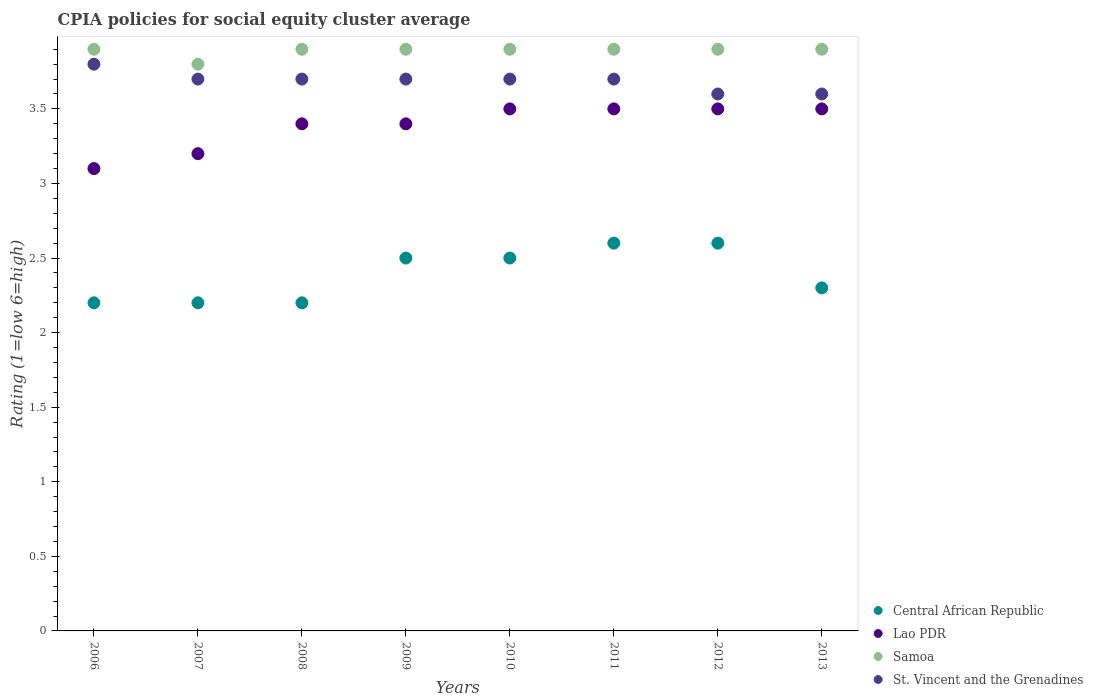How many different coloured dotlines are there?
Make the answer very short. 4. Is the number of dotlines equal to the number of legend labels?
Provide a succinct answer. Yes. Across all years, what is the maximum CPIA rating in St. Vincent and the Grenadines?
Offer a very short reply. 3.8. Across all years, what is the minimum CPIA rating in Lao PDR?
Your answer should be compact. 3.1. In which year was the CPIA rating in St. Vincent and the Grenadines minimum?
Ensure brevity in your answer.  2012. What is the total CPIA rating in Lao PDR in the graph?
Ensure brevity in your answer.  27.1. What is the difference between the CPIA rating in St. Vincent and the Grenadines in 2006 and the CPIA rating in Samoa in 2010?
Provide a succinct answer. -0.1. What is the average CPIA rating in St. Vincent and the Grenadines per year?
Ensure brevity in your answer.  3.69. In the year 2012, what is the difference between the CPIA rating in Lao PDR and CPIA rating in Central African Republic?
Keep it short and to the point. 0.9. What is the ratio of the CPIA rating in Lao PDR in 2006 to that in 2008?
Give a very brief answer. 0.91. Is the CPIA rating in Central African Republic in 2009 less than that in 2012?
Give a very brief answer. Yes. What is the difference between the highest and the second highest CPIA rating in St. Vincent and the Grenadines?
Keep it short and to the point. 0.1. What is the difference between the highest and the lowest CPIA rating in Samoa?
Make the answer very short. 0.1. In how many years, is the CPIA rating in Samoa greater than the average CPIA rating in Samoa taken over all years?
Give a very brief answer. 7. Is the sum of the CPIA rating in Lao PDR in 2008 and 2010 greater than the maximum CPIA rating in St. Vincent and the Grenadines across all years?
Provide a short and direct response. Yes. Does the CPIA rating in Central African Republic monotonically increase over the years?
Give a very brief answer. No. Is the CPIA rating in Lao PDR strictly greater than the CPIA rating in Samoa over the years?
Ensure brevity in your answer.  No. Is the CPIA rating in Samoa strictly less than the CPIA rating in Lao PDR over the years?
Provide a succinct answer. No. How many dotlines are there?
Offer a very short reply. 4. How many years are there in the graph?
Ensure brevity in your answer.  8. Are the values on the major ticks of Y-axis written in scientific E-notation?
Your answer should be very brief. No. Does the graph contain any zero values?
Offer a very short reply. No. Does the graph contain grids?
Your answer should be very brief. No. Where does the legend appear in the graph?
Provide a short and direct response. Bottom right. How many legend labels are there?
Provide a short and direct response. 4. How are the legend labels stacked?
Keep it short and to the point. Vertical. What is the title of the graph?
Ensure brevity in your answer.  CPIA policies for social equity cluster average. What is the label or title of the X-axis?
Give a very brief answer. Years. What is the Rating (1=low 6=high) of Lao PDR in 2006?
Ensure brevity in your answer.  3.1. What is the Rating (1=low 6=high) in St. Vincent and the Grenadines in 2006?
Give a very brief answer. 3.8. What is the Rating (1=low 6=high) of St. Vincent and the Grenadines in 2007?
Give a very brief answer. 3.7. What is the Rating (1=low 6=high) in Lao PDR in 2008?
Provide a succinct answer. 3.4. What is the Rating (1=low 6=high) in Samoa in 2008?
Your answer should be compact. 3.9. What is the Rating (1=low 6=high) of Samoa in 2010?
Offer a terse response. 3.9. What is the Rating (1=low 6=high) in St. Vincent and the Grenadines in 2010?
Make the answer very short. 3.7. What is the Rating (1=low 6=high) in Central African Republic in 2011?
Provide a succinct answer. 2.6. What is the Rating (1=low 6=high) of Lao PDR in 2011?
Provide a succinct answer. 3.5. What is the Rating (1=low 6=high) in Samoa in 2011?
Offer a terse response. 3.9. What is the Rating (1=low 6=high) of Central African Republic in 2012?
Ensure brevity in your answer.  2.6. What is the Rating (1=low 6=high) in Lao PDR in 2012?
Keep it short and to the point. 3.5. What is the Rating (1=low 6=high) in Samoa in 2012?
Make the answer very short. 3.9. What is the Rating (1=low 6=high) of St. Vincent and the Grenadines in 2012?
Your response must be concise. 3.6. What is the Rating (1=low 6=high) of Central African Republic in 2013?
Make the answer very short. 2.3. What is the Rating (1=low 6=high) in Lao PDR in 2013?
Make the answer very short. 3.5. Across all years, what is the maximum Rating (1=low 6=high) of Central African Republic?
Offer a terse response. 2.6. Across all years, what is the minimum Rating (1=low 6=high) in Samoa?
Offer a terse response. 3.8. Across all years, what is the minimum Rating (1=low 6=high) in St. Vincent and the Grenadines?
Offer a terse response. 3.6. What is the total Rating (1=low 6=high) of Lao PDR in the graph?
Give a very brief answer. 27.1. What is the total Rating (1=low 6=high) of Samoa in the graph?
Offer a very short reply. 31.1. What is the total Rating (1=low 6=high) in St. Vincent and the Grenadines in the graph?
Your response must be concise. 29.5. What is the difference between the Rating (1=low 6=high) in Central African Republic in 2006 and that in 2007?
Offer a very short reply. 0. What is the difference between the Rating (1=low 6=high) in Lao PDR in 2006 and that in 2007?
Make the answer very short. -0.1. What is the difference between the Rating (1=low 6=high) of Samoa in 2006 and that in 2007?
Offer a terse response. 0.1. What is the difference between the Rating (1=low 6=high) of Central African Republic in 2006 and that in 2008?
Your answer should be very brief. 0. What is the difference between the Rating (1=low 6=high) of St. Vincent and the Grenadines in 2006 and that in 2008?
Provide a succinct answer. 0.1. What is the difference between the Rating (1=low 6=high) of Central African Republic in 2006 and that in 2009?
Provide a short and direct response. -0.3. What is the difference between the Rating (1=low 6=high) of St. Vincent and the Grenadines in 2006 and that in 2009?
Provide a short and direct response. 0.1. What is the difference between the Rating (1=low 6=high) of Samoa in 2006 and that in 2010?
Your answer should be very brief. 0. What is the difference between the Rating (1=low 6=high) of Central African Republic in 2006 and that in 2011?
Give a very brief answer. -0.4. What is the difference between the Rating (1=low 6=high) of Lao PDR in 2006 and that in 2011?
Ensure brevity in your answer.  -0.4. What is the difference between the Rating (1=low 6=high) in St. Vincent and the Grenadines in 2006 and that in 2011?
Keep it short and to the point. 0.1. What is the difference between the Rating (1=low 6=high) of Samoa in 2006 and that in 2012?
Provide a succinct answer. 0. What is the difference between the Rating (1=low 6=high) of Central African Republic in 2006 and that in 2013?
Your response must be concise. -0.1. What is the difference between the Rating (1=low 6=high) in Lao PDR in 2006 and that in 2013?
Offer a very short reply. -0.4. What is the difference between the Rating (1=low 6=high) of Samoa in 2006 and that in 2013?
Ensure brevity in your answer.  0. What is the difference between the Rating (1=low 6=high) in St. Vincent and the Grenadines in 2006 and that in 2013?
Offer a very short reply. 0.2. What is the difference between the Rating (1=low 6=high) of Lao PDR in 2007 and that in 2008?
Provide a short and direct response. -0.2. What is the difference between the Rating (1=low 6=high) of Samoa in 2007 and that in 2008?
Make the answer very short. -0.1. What is the difference between the Rating (1=low 6=high) of St. Vincent and the Grenadines in 2007 and that in 2008?
Ensure brevity in your answer.  0. What is the difference between the Rating (1=low 6=high) of Central African Republic in 2007 and that in 2009?
Your response must be concise. -0.3. What is the difference between the Rating (1=low 6=high) of Samoa in 2007 and that in 2009?
Your response must be concise. -0.1. What is the difference between the Rating (1=low 6=high) in Central African Republic in 2007 and that in 2010?
Offer a very short reply. -0.3. What is the difference between the Rating (1=low 6=high) of Samoa in 2007 and that in 2010?
Keep it short and to the point. -0.1. What is the difference between the Rating (1=low 6=high) in St. Vincent and the Grenadines in 2007 and that in 2010?
Offer a very short reply. 0. What is the difference between the Rating (1=low 6=high) in Central African Republic in 2007 and that in 2011?
Your answer should be very brief. -0.4. What is the difference between the Rating (1=low 6=high) in Lao PDR in 2007 and that in 2011?
Offer a very short reply. -0.3. What is the difference between the Rating (1=low 6=high) in Samoa in 2007 and that in 2011?
Make the answer very short. -0.1. What is the difference between the Rating (1=low 6=high) in St. Vincent and the Grenadines in 2007 and that in 2012?
Provide a short and direct response. 0.1. What is the difference between the Rating (1=low 6=high) in Lao PDR in 2007 and that in 2013?
Your answer should be compact. -0.3. What is the difference between the Rating (1=low 6=high) of Central African Republic in 2008 and that in 2009?
Make the answer very short. -0.3. What is the difference between the Rating (1=low 6=high) of Lao PDR in 2008 and that in 2009?
Your answer should be very brief. 0. What is the difference between the Rating (1=low 6=high) in St. Vincent and the Grenadines in 2008 and that in 2009?
Your answer should be compact. 0. What is the difference between the Rating (1=low 6=high) in Lao PDR in 2008 and that in 2010?
Offer a terse response. -0.1. What is the difference between the Rating (1=low 6=high) in Samoa in 2008 and that in 2010?
Keep it short and to the point. 0. What is the difference between the Rating (1=low 6=high) of St. Vincent and the Grenadines in 2008 and that in 2010?
Offer a very short reply. 0. What is the difference between the Rating (1=low 6=high) of Central African Republic in 2008 and that in 2011?
Provide a short and direct response. -0.4. What is the difference between the Rating (1=low 6=high) of Samoa in 2008 and that in 2011?
Make the answer very short. 0. What is the difference between the Rating (1=low 6=high) in St. Vincent and the Grenadines in 2008 and that in 2011?
Make the answer very short. 0. What is the difference between the Rating (1=low 6=high) in Samoa in 2008 and that in 2012?
Your answer should be compact. 0. What is the difference between the Rating (1=low 6=high) of Central African Republic in 2008 and that in 2013?
Make the answer very short. -0.1. What is the difference between the Rating (1=low 6=high) in Samoa in 2008 and that in 2013?
Offer a terse response. 0. What is the difference between the Rating (1=low 6=high) in Central African Republic in 2009 and that in 2010?
Make the answer very short. 0. What is the difference between the Rating (1=low 6=high) of Lao PDR in 2009 and that in 2010?
Make the answer very short. -0.1. What is the difference between the Rating (1=low 6=high) of Samoa in 2009 and that in 2010?
Your response must be concise. 0. What is the difference between the Rating (1=low 6=high) of St. Vincent and the Grenadines in 2009 and that in 2010?
Offer a terse response. 0. What is the difference between the Rating (1=low 6=high) in Central African Republic in 2009 and that in 2011?
Give a very brief answer. -0.1. What is the difference between the Rating (1=low 6=high) of Lao PDR in 2009 and that in 2011?
Keep it short and to the point. -0.1. What is the difference between the Rating (1=low 6=high) in St. Vincent and the Grenadines in 2009 and that in 2011?
Provide a short and direct response. 0. What is the difference between the Rating (1=low 6=high) in Samoa in 2009 and that in 2012?
Your answer should be very brief. 0. What is the difference between the Rating (1=low 6=high) in Lao PDR in 2009 and that in 2013?
Make the answer very short. -0.1. What is the difference between the Rating (1=low 6=high) in St. Vincent and the Grenadines in 2009 and that in 2013?
Offer a terse response. 0.1. What is the difference between the Rating (1=low 6=high) in Lao PDR in 2010 and that in 2011?
Offer a terse response. 0. What is the difference between the Rating (1=low 6=high) of Samoa in 2010 and that in 2011?
Provide a succinct answer. 0. What is the difference between the Rating (1=low 6=high) in Central African Republic in 2010 and that in 2012?
Ensure brevity in your answer.  -0.1. What is the difference between the Rating (1=low 6=high) of Central African Republic in 2010 and that in 2013?
Ensure brevity in your answer.  0.2. What is the difference between the Rating (1=low 6=high) of Lao PDR in 2010 and that in 2013?
Your answer should be compact. 0. What is the difference between the Rating (1=low 6=high) of St. Vincent and the Grenadines in 2010 and that in 2013?
Offer a very short reply. 0.1. What is the difference between the Rating (1=low 6=high) of Lao PDR in 2011 and that in 2012?
Provide a succinct answer. 0. What is the difference between the Rating (1=low 6=high) in Samoa in 2011 and that in 2012?
Make the answer very short. 0. What is the difference between the Rating (1=low 6=high) of St. Vincent and the Grenadines in 2011 and that in 2012?
Offer a terse response. 0.1. What is the difference between the Rating (1=low 6=high) of Central African Republic in 2011 and that in 2013?
Provide a succinct answer. 0.3. What is the difference between the Rating (1=low 6=high) of Lao PDR in 2011 and that in 2013?
Provide a succinct answer. 0. What is the difference between the Rating (1=low 6=high) in Samoa in 2011 and that in 2013?
Your response must be concise. 0. What is the difference between the Rating (1=low 6=high) in Central African Republic in 2012 and that in 2013?
Keep it short and to the point. 0.3. What is the difference between the Rating (1=low 6=high) in Samoa in 2012 and that in 2013?
Your answer should be very brief. 0. What is the difference between the Rating (1=low 6=high) in St. Vincent and the Grenadines in 2012 and that in 2013?
Make the answer very short. 0. What is the difference between the Rating (1=low 6=high) in Central African Republic in 2006 and the Rating (1=low 6=high) in Lao PDR in 2007?
Your response must be concise. -1. What is the difference between the Rating (1=low 6=high) of Central African Republic in 2006 and the Rating (1=low 6=high) of Samoa in 2007?
Keep it short and to the point. -1.6. What is the difference between the Rating (1=low 6=high) of Central African Republic in 2006 and the Rating (1=low 6=high) of St. Vincent and the Grenadines in 2007?
Offer a terse response. -1.5. What is the difference between the Rating (1=low 6=high) of Lao PDR in 2006 and the Rating (1=low 6=high) of St. Vincent and the Grenadines in 2007?
Keep it short and to the point. -0.6. What is the difference between the Rating (1=low 6=high) in Central African Republic in 2006 and the Rating (1=low 6=high) in Samoa in 2008?
Keep it short and to the point. -1.7. What is the difference between the Rating (1=low 6=high) of Lao PDR in 2006 and the Rating (1=low 6=high) of St. Vincent and the Grenadines in 2008?
Ensure brevity in your answer.  -0.6. What is the difference between the Rating (1=low 6=high) in Samoa in 2006 and the Rating (1=low 6=high) in St. Vincent and the Grenadines in 2008?
Provide a succinct answer. 0.2. What is the difference between the Rating (1=low 6=high) in Lao PDR in 2006 and the Rating (1=low 6=high) in St. Vincent and the Grenadines in 2009?
Ensure brevity in your answer.  -0.6. What is the difference between the Rating (1=low 6=high) in Central African Republic in 2006 and the Rating (1=low 6=high) in Lao PDR in 2010?
Ensure brevity in your answer.  -1.3. What is the difference between the Rating (1=low 6=high) in Central African Republic in 2006 and the Rating (1=low 6=high) in Samoa in 2010?
Provide a short and direct response. -1.7. What is the difference between the Rating (1=low 6=high) of Central African Republic in 2006 and the Rating (1=low 6=high) of St. Vincent and the Grenadines in 2010?
Your response must be concise. -1.5. What is the difference between the Rating (1=low 6=high) in Samoa in 2006 and the Rating (1=low 6=high) in St. Vincent and the Grenadines in 2010?
Give a very brief answer. 0.2. What is the difference between the Rating (1=low 6=high) of Central African Republic in 2006 and the Rating (1=low 6=high) of St. Vincent and the Grenadines in 2011?
Your answer should be very brief. -1.5. What is the difference between the Rating (1=low 6=high) of Lao PDR in 2006 and the Rating (1=low 6=high) of Samoa in 2011?
Give a very brief answer. -0.8. What is the difference between the Rating (1=low 6=high) of Central African Republic in 2006 and the Rating (1=low 6=high) of Samoa in 2013?
Offer a terse response. -1.7. What is the difference between the Rating (1=low 6=high) in Lao PDR in 2006 and the Rating (1=low 6=high) in Samoa in 2013?
Your answer should be very brief. -0.8. What is the difference between the Rating (1=low 6=high) of Samoa in 2006 and the Rating (1=low 6=high) of St. Vincent and the Grenadines in 2013?
Your answer should be very brief. 0.3. What is the difference between the Rating (1=low 6=high) of Central African Republic in 2007 and the Rating (1=low 6=high) of St. Vincent and the Grenadines in 2008?
Your answer should be compact. -1.5. What is the difference between the Rating (1=low 6=high) of Lao PDR in 2007 and the Rating (1=low 6=high) of Samoa in 2008?
Give a very brief answer. -0.7. What is the difference between the Rating (1=low 6=high) of Lao PDR in 2007 and the Rating (1=low 6=high) of St. Vincent and the Grenadines in 2008?
Give a very brief answer. -0.5. What is the difference between the Rating (1=low 6=high) in Samoa in 2007 and the Rating (1=low 6=high) in St. Vincent and the Grenadines in 2008?
Your answer should be very brief. 0.1. What is the difference between the Rating (1=low 6=high) of Central African Republic in 2007 and the Rating (1=low 6=high) of Samoa in 2009?
Provide a short and direct response. -1.7. What is the difference between the Rating (1=low 6=high) in Central African Republic in 2007 and the Rating (1=low 6=high) in St. Vincent and the Grenadines in 2009?
Give a very brief answer. -1.5. What is the difference between the Rating (1=low 6=high) of Lao PDR in 2007 and the Rating (1=low 6=high) of Samoa in 2009?
Your answer should be compact. -0.7. What is the difference between the Rating (1=low 6=high) in Lao PDR in 2007 and the Rating (1=low 6=high) in St. Vincent and the Grenadines in 2009?
Give a very brief answer. -0.5. What is the difference between the Rating (1=low 6=high) in Central African Republic in 2007 and the Rating (1=low 6=high) in Lao PDR in 2010?
Your response must be concise. -1.3. What is the difference between the Rating (1=low 6=high) in Central African Republic in 2007 and the Rating (1=low 6=high) in St. Vincent and the Grenadines in 2010?
Provide a succinct answer. -1.5. What is the difference between the Rating (1=low 6=high) of Samoa in 2007 and the Rating (1=low 6=high) of St. Vincent and the Grenadines in 2010?
Make the answer very short. 0.1. What is the difference between the Rating (1=low 6=high) in Central African Republic in 2007 and the Rating (1=low 6=high) in Lao PDR in 2011?
Give a very brief answer. -1.3. What is the difference between the Rating (1=low 6=high) in Lao PDR in 2007 and the Rating (1=low 6=high) in St. Vincent and the Grenadines in 2011?
Your answer should be compact. -0.5. What is the difference between the Rating (1=low 6=high) of Samoa in 2007 and the Rating (1=low 6=high) of St. Vincent and the Grenadines in 2011?
Your response must be concise. 0.1. What is the difference between the Rating (1=low 6=high) in Central African Republic in 2007 and the Rating (1=low 6=high) in Lao PDR in 2012?
Make the answer very short. -1.3. What is the difference between the Rating (1=low 6=high) of Central African Republic in 2007 and the Rating (1=low 6=high) of St. Vincent and the Grenadines in 2012?
Make the answer very short. -1.4. What is the difference between the Rating (1=low 6=high) in Central African Republic in 2007 and the Rating (1=low 6=high) in Lao PDR in 2013?
Provide a short and direct response. -1.3. What is the difference between the Rating (1=low 6=high) in Central African Republic in 2007 and the Rating (1=low 6=high) in Samoa in 2013?
Provide a succinct answer. -1.7. What is the difference between the Rating (1=low 6=high) of Lao PDR in 2007 and the Rating (1=low 6=high) of Samoa in 2013?
Your response must be concise. -0.7. What is the difference between the Rating (1=low 6=high) of Lao PDR in 2007 and the Rating (1=low 6=high) of St. Vincent and the Grenadines in 2013?
Offer a very short reply. -0.4. What is the difference between the Rating (1=low 6=high) of Central African Republic in 2008 and the Rating (1=low 6=high) of St. Vincent and the Grenadines in 2009?
Provide a short and direct response. -1.5. What is the difference between the Rating (1=low 6=high) of Lao PDR in 2008 and the Rating (1=low 6=high) of Samoa in 2009?
Give a very brief answer. -0.5. What is the difference between the Rating (1=low 6=high) in Central African Republic in 2008 and the Rating (1=low 6=high) in Lao PDR in 2010?
Give a very brief answer. -1.3. What is the difference between the Rating (1=low 6=high) in Central African Republic in 2008 and the Rating (1=low 6=high) in Samoa in 2010?
Give a very brief answer. -1.7. What is the difference between the Rating (1=low 6=high) in Central African Republic in 2008 and the Rating (1=low 6=high) in St. Vincent and the Grenadines in 2011?
Provide a short and direct response. -1.5. What is the difference between the Rating (1=low 6=high) in Samoa in 2008 and the Rating (1=low 6=high) in St. Vincent and the Grenadines in 2011?
Offer a terse response. 0.2. What is the difference between the Rating (1=low 6=high) of Central African Republic in 2008 and the Rating (1=low 6=high) of Lao PDR in 2012?
Make the answer very short. -1.3. What is the difference between the Rating (1=low 6=high) of Central African Republic in 2008 and the Rating (1=low 6=high) of Samoa in 2012?
Offer a very short reply. -1.7. What is the difference between the Rating (1=low 6=high) of Central African Republic in 2008 and the Rating (1=low 6=high) of St. Vincent and the Grenadines in 2012?
Your answer should be very brief. -1.4. What is the difference between the Rating (1=low 6=high) in Lao PDR in 2008 and the Rating (1=low 6=high) in Samoa in 2012?
Provide a short and direct response. -0.5. What is the difference between the Rating (1=low 6=high) in Central African Republic in 2008 and the Rating (1=low 6=high) in Lao PDR in 2013?
Your answer should be very brief. -1.3. What is the difference between the Rating (1=low 6=high) in Central African Republic in 2008 and the Rating (1=low 6=high) in Samoa in 2013?
Give a very brief answer. -1.7. What is the difference between the Rating (1=low 6=high) of Lao PDR in 2008 and the Rating (1=low 6=high) of Samoa in 2013?
Offer a terse response. -0.5. What is the difference between the Rating (1=low 6=high) of Samoa in 2008 and the Rating (1=low 6=high) of St. Vincent and the Grenadines in 2013?
Make the answer very short. 0.3. What is the difference between the Rating (1=low 6=high) of Central African Republic in 2009 and the Rating (1=low 6=high) of St. Vincent and the Grenadines in 2010?
Give a very brief answer. -1.2. What is the difference between the Rating (1=low 6=high) of Lao PDR in 2009 and the Rating (1=low 6=high) of Samoa in 2010?
Provide a short and direct response. -0.5. What is the difference between the Rating (1=low 6=high) in Central African Republic in 2009 and the Rating (1=low 6=high) in Samoa in 2011?
Ensure brevity in your answer.  -1.4. What is the difference between the Rating (1=low 6=high) in Central African Republic in 2009 and the Rating (1=low 6=high) in St. Vincent and the Grenadines in 2011?
Give a very brief answer. -1.2. What is the difference between the Rating (1=low 6=high) of Central African Republic in 2009 and the Rating (1=low 6=high) of Lao PDR in 2012?
Your response must be concise. -1. What is the difference between the Rating (1=low 6=high) of Lao PDR in 2009 and the Rating (1=low 6=high) of Samoa in 2012?
Your answer should be very brief. -0.5. What is the difference between the Rating (1=low 6=high) in Samoa in 2009 and the Rating (1=low 6=high) in St. Vincent and the Grenadines in 2012?
Your answer should be very brief. 0.3. What is the difference between the Rating (1=low 6=high) in Central African Republic in 2009 and the Rating (1=low 6=high) in Samoa in 2013?
Make the answer very short. -1.4. What is the difference between the Rating (1=low 6=high) in Central African Republic in 2009 and the Rating (1=low 6=high) in St. Vincent and the Grenadines in 2013?
Your answer should be compact. -1.1. What is the difference between the Rating (1=low 6=high) in Lao PDR in 2009 and the Rating (1=low 6=high) in Samoa in 2013?
Your answer should be compact. -0.5. What is the difference between the Rating (1=low 6=high) of Central African Republic in 2010 and the Rating (1=low 6=high) of Samoa in 2011?
Your answer should be compact. -1.4. What is the difference between the Rating (1=low 6=high) in Central African Republic in 2010 and the Rating (1=low 6=high) in St. Vincent and the Grenadines in 2011?
Your answer should be very brief. -1.2. What is the difference between the Rating (1=low 6=high) in Lao PDR in 2010 and the Rating (1=low 6=high) in Samoa in 2011?
Your answer should be compact. -0.4. What is the difference between the Rating (1=low 6=high) of Samoa in 2010 and the Rating (1=low 6=high) of St. Vincent and the Grenadines in 2011?
Provide a succinct answer. 0.2. What is the difference between the Rating (1=low 6=high) of Central African Republic in 2010 and the Rating (1=low 6=high) of Lao PDR in 2012?
Offer a very short reply. -1. What is the difference between the Rating (1=low 6=high) of Central African Republic in 2010 and the Rating (1=low 6=high) of Samoa in 2012?
Provide a succinct answer. -1.4. What is the difference between the Rating (1=low 6=high) of Lao PDR in 2010 and the Rating (1=low 6=high) of Samoa in 2012?
Your answer should be very brief. -0.4. What is the difference between the Rating (1=low 6=high) of Lao PDR in 2010 and the Rating (1=low 6=high) of St. Vincent and the Grenadines in 2012?
Offer a terse response. -0.1. What is the difference between the Rating (1=low 6=high) of Samoa in 2010 and the Rating (1=low 6=high) of St. Vincent and the Grenadines in 2012?
Your answer should be very brief. 0.3. What is the difference between the Rating (1=low 6=high) of Central African Republic in 2010 and the Rating (1=low 6=high) of St. Vincent and the Grenadines in 2013?
Keep it short and to the point. -1.1. What is the difference between the Rating (1=low 6=high) in Lao PDR in 2010 and the Rating (1=low 6=high) in St. Vincent and the Grenadines in 2013?
Your answer should be compact. -0.1. What is the difference between the Rating (1=low 6=high) of Central African Republic in 2011 and the Rating (1=low 6=high) of Samoa in 2012?
Offer a very short reply. -1.3. What is the difference between the Rating (1=low 6=high) in Central African Republic in 2011 and the Rating (1=low 6=high) in St. Vincent and the Grenadines in 2012?
Make the answer very short. -1. What is the difference between the Rating (1=low 6=high) of Lao PDR in 2011 and the Rating (1=low 6=high) of Samoa in 2012?
Provide a short and direct response. -0.4. What is the difference between the Rating (1=low 6=high) of Lao PDR in 2011 and the Rating (1=low 6=high) of St. Vincent and the Grenadines in 2012?
Your response must be concise. -0.1. What is the difference between the Rating (1=low 6=high) of Central African Republic in 2011 and the Rating (1=low 6=high) of Lao PDR in 2013?
Keep it short and to the point. -0.9. What is the difference between the Rating (1=low 6=high) in Central African Republic in 2011 and the Rating (1=low 6=high) in Samoa in 2013?
Your response must be concise. -1.3. What is the difference between the Rating (1=low 6=high) in Lao PDR in 2011 and the Rating (1=low 6=high) in Samoa in 2013?
Give a very brief answer. -0.4. What is the difference between the Rating (1=low 6=high) of Lao PDR in 2011 and the Rating (1=low 6=high) of St. Vincent and the Grenadines in 2013?
Make the answer very short. -0.1. What is the difference between the Rating (1=low 6=high) of Central African Republic in 2012 and the Rating (1=low 6=high) of Lao PDR in 2013?
Offer a terse response. -0.9. What is the difference between the Rating (1=low 6=high) in Central African Republic in 2012 and the Rating (1=low 6=high) in St. Vincent and the Grenadines in 2013?
Provide a succinct answer. -1. What is the difference between the Rating (1=low 6=high) of Lao PDR in 2012 and the Rating (1=low 6=high) of Samoa in 2013?
Your answer should be very brief. -0.4. What is the difference between the Rating (1=low 6=high) in Lao PDR in 2012 and the Rating (1=low 6=high) in St. Vincent and the Grenadines in 2013?
Provide a succinct answer. -0.1. What is the difference between the Rating (1=low 6=high) in Samoa in 2012 and the Rating (1=low 6=high) in St. Vincent and the Grenadines in 2013?
Keep it short and to the point. 0.3. What is the average Rating (1=low 6=high) of Central African Republic per year?
Offer a terse response. 2.39. What is the average Rating (1=low 6=high) in Lao PDR per year?
Your response must be concise. 3.39. What is the average Rating (1=low 6=high) in Samoa per year?
Offer a terse response. 3.89. What is the average Rating (1=low 6=high) in St. Vincent and the Grenadines per year?
Offer a terse response. 3.69. In the year 2006, what is the difference between the Rating (1=low 6=high) in Central African Republic and Rating (1=low 6=high) in Lao PDR?
Make the answer very short. -0.9. In the year 2006, what is the difference between the Rating (1=low 6=high) of Central African Republic and Rating (1=low 6=high) of St. Vincent and the Grenadines?
Make the answer very short. -1.6. In the year 2006, what is the difference between the Rating (1=low 6=high) of Lao PDR and Rating (1=low 6=high) of Samoa?
Make the answer very short. -0.8. In the year 2006, what is the difference between the Rating (1=low 6=high) in Lao PDR and Rating (1=low 6=high) in St. Vincent and the Grenadines?
Your answer should be very brief. -0.7. In the year 2007, what is the difference between the Rating (1=low 6=high) in Central African Republic and Rating (1=low 6=high) in Lao PDR?
Keep it short and to the point. -1. In the year 2007, what is the difference between the Rating (1=low 6=high) in Central African Republic and Rating (1=low 6=high) in Samoa?
Ensure brevity in your answer.  -1.6. In the year 2007, what is the difference between the Rating (1=low 6=high) of Lao PDR and Rating (1=low 6=high) of St. Vincent and the Grenadines?
Make the answer very short. -0.5. In the year 2007, what is the difference between the Rating (1=low 6=high) of Samoa and Rating (1=low 6=high) of St. Vincent and the Grenadines?
Your answer should be very brief. 0.1. In the year 2008, what is the difference between the Rating (1=low 6=high) of Central African Republic and Rating (1=low 6=high) of Lao PDR?
Your answer should be very brief. -1.2. In the year 2008, what is the difference between the Rating (1=low 6=high) of Central African Republic and Rating (1=low 6=high) of St. Vincent and the Grenadines?
Provide a succinct answer. -1.5. In the year 2009, what is the difference between the Rating (1=low 6=high) in Central African Republic and Rating (1=low 6=high) in St. Vincent and the Grenadines?
Make the answer very short. -1.2. In the year 2009, what is the difference between the Rating (1=low 6=high) in Lao PDR and Rating (1=low 6=high) in Samoa?
Keep it short and to the point. -0.5. In the year 2010, what is the difference between the Rating (1=low 6=high) of Central African Republic and Rating (1=low 6=high) of Lao PDR?
Provide a succinct answer. -1. In the year 2010, what is the difference between the Rating (1=low 6=high) of Central African Republic and Rating (1=low 6=high) of St. Vincent and the Grenadines?
Offer a terse response. -1.2. In the year 2010, what is the difference between the Rating (1=low 6=high) of Lao PDR and Rating (1=low 6=high) of Samoa?
Keep it short and to the point. -0.4. In the year 2010, what is the difference between the Rating (1=low 6=high) of Lao PDR and Rating (1=low 6=high) of St. Vincent and the Grenadines?
Ensure brevity in your answer.  -0.2. In the year 2011, what is the difference between the Rating (1=low 6=high) in Central African Republic and Rating (1=low 6=high) in Samoa?
Provide a short and direct response. -1.3. In the year 2011, what is the difference between the Rating (1=low 6=high) in Central African Republic and Rating (1=low 6=high) in St. Vincent and the Grenadines?
Keep it short and to the point. -1.1. In the year 2011, what is the difference between the Rating (1=low 6=high) in Lao PDR and Rating (1=low 6=high) in Samoa?
Provide a short and direct response. -0.4. In the year 2012, what is the difference between the Rating (1=low 6=high) in Central African Republic and Rating (1=low 6=high) in Lao PDR?
Give a very brief answer. -0.9. In the year 2012, what is the difference between the Rating (1=low 6=high) in Lao PDR and Rating (1=low 6=high) in Samoa?
Provide a short and direct response. -0.4. In the year 2012, what is the difference between the Rating (1=low 6=high) in Lao PDR and Rating (1=low 6=high) in St. Vincent and the Grenadines?
Provide a succinct answer. -0.1. In the year 2012, what is the difference between the Rating (1=low 6=high) in Samoa and Rating (1=low 6=high) in St. Vincent and the Grenadines?
Offer a very short reply. 0.3. In the year 2013, what is the difference between the Rating (1=low 6=high) in Central African Republic and Rating (1=low 6=high) in St. Vincent and the Grenadines?
Your response must be concise. -1.3. In the year 2013, what is the difference between the Rating (1=low 6=high) in Lao PDR and Rating (1=low 6=high) in Samoa?
Offer a terse response. -0.4. In the year 2013, what is the difference between the Rating (1=low 6=high) of Samoa and Rating (1=low 6=high) of St. Vincent and the Grenadines?
Offer a terse response. 0.3. What is the ratio of the Rating (1=low 6=high) of Central African Republic in 2006 to that in 2007?
Offer a very short reply. 1. What is the ratio of the Rating (1=low 6=high) of Lao PDR in 2006 to that in 2007?
Your answer should be compact. 0.97. What is the ratio of the Rating (1=low 6=high) of Samoa in 2006 to that in 2007?
Keep it short and to the point. 1.03. What is the ratio of the Rating (1=low 6=high) in Lao PDR in 2006 to that in 2008?
Your answer should be very brief. 0.91. What is the ratio of the Rating (1=low 6=high) of Samoa in 2006 to that in 2008?
Offer a terse response. 1. What is the ratio of the Rating (1=low 6=high) of Central African Republic in 2006 to that in 2009?
Ensure brevity in your answer.  0.88. What is the ratio of the Rating (1=low 6=high) of Lao PDR in 2006 to that in 2009?
Keep it short and to the point. 0.91. What is the ratio of the Rating (1=low 6=high) in St. Vincent and the Grenadines in 2006 to that in 2009?
Keep it short and to the point. 1.03. What is the ratio of the Rating (1=low 6=high) of Central African Republic in 2006 to that in 2010?
Your response must be concise. 0.88. What is the ratio of the Rating (1=low 6=high) in Lao PDR in 2006 to that in 2010?
Ensure brevity in your answer.  0.89. What is the ratio of the Rating (1=low 6=high) of Central African Republic in 2006 to that in 2011?
Offer a terse response. 0.85. What is the ratio of the Rating (1=low 6=high) in Lao PDR in 2006 to that in 2011?
Give a very brief answer. 0.89. What is the ratio of the Rating (1=low 6=high) of Samoa in 2006 to that in 2011?
Offer a terse response. 1. What is the ratio of the Rating (1=low 6=high) of Central African Republic in 2006 to that in 2012?
Keep it short and to the point. 0.85. What is the ratio of the Rating (1=low 6=high) of Lao PDR in 2006 to that in 2012?
Provide a succinct answer. 0.89. What is the ratio of the Rating (1=low 6=high) in Samoa in 2006 to that in 2012?
Your answer should be very brief. 1. What is the ratio of the Rating (1=low 6=high) of St. Vincent and the Grenadines in 2006 to that in 2012?
Offer a terse response. 1.06. What is the ratio of the Rating (1=low 6=high) of Central African Republic in 2006 to that in 2013?
Provide a succinct answer. 0.96. What is the ratio of the Rating (1=low 6=high) in Lao PDR in 2006 to that in 2013?
Your response must be concise. 0.89. What is the ratio of the Rating (1=low 6=high) in Samoa in 2006 to that in 2013?
Give a very brief answer. 1. What is the ratio of the Rating (1=low 6=high) in St. Vincent and the Grenadines in 2006 to that in 2013?
Your answer should be very brief. 1.06. What is the ratio of the Rating (1=low 6=high) of Lao PDR in 2007 to that in 2008?
Provide a succinct answer. 0.94. What is the ratio of the Rating (1=low 6=high) of Samoa in 2007 to that in 2008?
Your answer should be very brief. 0.97. What is the ratio of the Rating (1=low 6=high) of St. Vincent and the Grenadines in 2007 to that in 2008?
Your answer should be very brief. 1. What is the ratio of the Rating (1=low 6=high) of Central African Republic in 2007 to that in 2009?
Provide a succinct answer. 0.88. What is the ratio of the Rating (1=low 6=high) of Lao PDR in 2007 to that in 2009?
Offer a very short reply. 0.94. What is the ratio of the Rating (1=low 6=high) in Samoa in 2007 to that in 2009?
Offer a very short reply. 0.97. What is the ratio of the Rating (1=low 6=high) of St. Vincent and the Grenadines in 2007 to that in 2009?
Your response must be concise. 1. What is the ratio of the Rating (1=low 6=high) of Central African Republic in 2007 to that in 2010?
Your answer should be very brief. 0.88. What is the ratio of the Rating (1=low 6=high) of Lao PDR in 2007 to that in 2010?
Keep it short and to the point. 0.91. What is the ratio of the Rating (1=low 6=high) in Samoa in 2007 to that in 2010?
Your answer should be very brief. 0.97. What is the ratio of the Rating (1=low 6=high) of St. Vincent and the Grenadines in 2007 to that in 2010?
Your answer should be very brief. 1. What is the ratio of the Rating (1=low 6=high) of Central African Republic in 2007 to that in 2011?
Your answer should be compact. 0.85. What is the ratio of the Rating (1=low 6=high) in Lao PDR in 2007 to that in 2011?
Offer a very short reply. 0.91. What is the ratio of the Rating (1=low 6=high) in Samoa in 2007 to that in 2011?
Give a very brief answer. 0.97. What is the ratio of the Rating (1=low 6=high) in St. Vincent and the Grenadines in 2007 to that in 2011?
Provide a succinct answer. 1. What is the ratio of the Rating (1=low 6=high) in Central African Republic in 2007 to that in 2012?
Provide a short and direct response. 0.85. What is the ratio of the Rating (1=low 6=high) of Lao PDR in 2007 to that in 2012?
Offer a very short reply. 0.91. What is the ratio of the Rating (1=low 6=high) in Samoa in 2007 to that in 2012?
Offer a terse response. 0.97. What is the ratio of the Rating (1=low 6=high) in St. Vincent and the Grenadines in 2007 to that in 2012?
Make the answer very short. 1.03. What is the ratio of the Rating (1=low 6=high) in Central African Republic in 2007 to that in 2013?
Your response must be concise. 0.96. What is the ratio of the Rating (1=low 6=high) in Lao PDR in 2007 to that in 2013?
Provide a short and direct response. 0.91. What is the ratio of the Rating (1=low 6=high) in Samoa in 2007 to that in 2013?
Provide a succinct answer. 0.97. What is the ratio of the Rating (1=low 6=high) of St. Vincent and the Grenadines in 2007 to that in 2013?
Your answer should be compact. 1.03. What is the ratio of the Rating (1=low 6=high) in Central African Republic in 2008 to that in 2009?
Give a very brief answer. 0.88. What is the ratio of the Rating (1=low 6=high) in Lao PDR in 2008 to that in 2009?
Your answer should be compact. 1. What is the ratio of the Rating (1=low 6=high) of St. Vincent and the Grenadines in 2008 to that in 2009?
Offer a very short reply. 1. What is the ratio of the Rating (1=low 6=high) in Central African Republic in 2008 to that in 2010?
Keep it short and to the point. 0.88. What is the ratio of the Rating (1=low 6=high) in Lao PDR in 2008 to that in 2010?
Give a very brief answer. 0.97. What is the ratio of the Rating (1=low 6=high) of Samoa in 2008 to that in 2010?
Your response must be concise. 1. What is the ratio of the Rating (1=low 6=high) of St. Vincent and the Grenadines in 2008 to that in 2010?
Your response must be concise. 1. What is the ratio of the Rating (1=low 6=high) in Central African Republic in 2008 to that in 2011?
Your answer should be very brief. 0.85. What is the ratio of the Rating (1=low 6=high) in Lao PDR in 2008 to that in 2011?
Make the answer very short. 0.97. What is the ratio of the Rating (1=low 6=high) in Samoa in 2008 to that in 2011?
Make the answer very short. 1. What is the ratio of the Rating (1=low 6=high) in St. Vincent and the Grenadines in 2008 to that in 2011?
Your answer should be compact. 1. What is the ratio of the Rating (1=low 6=high) in Central African Republic in 2008 to that in 2012?
Keep it short and to the point. 0.85. What is the ratio of the Rating (1=low 6=high) in Lao PDR in 2008 to that in 2012?
Ensure brevity in your answer.  0.97. What is the ratio of the Rating (1=low 6=high) in St. Vincent and the Grenadines in 2008 to that in 2012?
Keep it short and to the point. 1.03. What is the ratio of the Rating (1=low 6=high) of Central African Republic in 2008 to that in 2013?
Give a very brief answer. 0.96. What is the ratio of the Rating (1=low 6=high) in Lao PDR in 2008 to that in 2013?
Provide a short and direct response. 0.97. What is the ratio of the Rating (1=low 6=high) of Samoa in 2008 to that in 2013?
Give a very brief answer. 1. What is the ratio of the Rating (1=low 6=high) in St. Vincent and the Grenadines in 2008 to that in 2013?
Offer a very short reply. 1.03. What is the ratio of the Rating (1=low 6=high) of Central African Republic in 2009 to that in 2010?
Offer a very short reply. 1. What is the ratio of the Rating (1=low 6=high) of Lao PDR in 2009 to that in 2010?
Your response must be concise. 0.97. What is the ratio of the Rating (1=low 6=high) in Samoa in 2009 to that in 2010?
Keep it short and to the point. 1. What is the ratio of the Rating (1=low 6=high) in St. Vincent and the Grenadines in 2009 to that in 2010?
Keep it short and to the point. 1. What is the ratio of the Rating (1=low 6=high) in Central African Republic in 2009 to that in 2011?
Your response must be concise. 0.96. What is the ratio of the Rating (1=low 6=high) in Lao PDR in 2009 to that in 2011?
Offer a terse response. 0.97. What is the ratio of the Rating (1=low 6=high) in Samoa in 2009 to that in 2011?
Your answer should be very brief. 1. What is the ratio of the Rating (1=low 6=high) in Central African Republic in 2009 to that in 2012?
Ensure brevity in your answer.  0.96. What is the ratio of the Rating (1=low 6=high) in Lao PDR in 2009 to that in 2012?
Give a very brief answer. 0.97. What is the ratio of the Rating (1=low 6=high) of Samoa in 2009 to that in 2012?
Your answer should be compact. 1. What is the ratio of the Rating (1=low 6=high) of St. Vincent and the Grenadines in 2009 to that in 2012?
Keep it short and to the point. 1.03. What is the ratio of the Rating (1=low 6=high) in Central African Republic in 2009 to that in 2013?
Make the answer very short. 1.09. What is the ratio of the Rating (1=low 6=high) in Lao PDR in 2009 to that in 2013?
Provide a short and direct response. 0.97. What is the ratio of the Rating (1=low 6=high) of Samoa in 2009 to that in 2013?
Your answer should be compact. 1. What is the ratio of the Rating (1=low 6=high) of St. Vincent and the Grenadines in 2009 to that in 2013?
Offer a very short reply. 1.03. What is the ratio of the Rating (1=low 6=high) of Central African Republic in 2010 to that in 2011?
Keep it short and to the point. 0.96. What is the ratio of the Rating (1=low 6=high) in Lao PDR in 2010 to that in 2011?
Offer a very short reply. 1. What is the ratio of the Rating (1=low 6=high) of Samoa in 2010 to that in 2011?
Offer a terse response. 1. What is the ratio of the Rating (1=low 6=high) in St. Vincent and the Grenadines in 2010 to that in 2011?
Ensure brevity in your answer.  1. What is the ratio of the Rating (1=low 6=high) in Central African Republic in 2010 to that in 2012?
Provide a short and direct response. 0.96. What is the ratio of the Rating (1=low 6=high) in Samoa in 2010 to that in 2012?
Your response must be concise. 1. What is the ratio of the Rating (1=low 6=high) of St. Vincent and the Grenadines in 2010 to that in 2012?
Offer a very short reply. 1.03. What is the ratio of the Rating (1=low 6=high) of Central African Republic in 2010 to that in 2013?
Your answer should be compact. 1.09. What is the ratio of the Rating (1=low 6=high) in Samoa in 2010 to that in 2013?
Your answer should be compact. 1. What is the ratio of the Rating (1=low 6=high) of St. Vincent and the Grenadines in 2010 to that in 2013?
Ensure brevity in your answer.  1.03. What is the ratio of the Rating (1=low 6=high) in Central African Republic in 2011 to that in 2012?
Your answer should be very brief. 1. What is the ratio of the Rating (1=low 6=high) in Samoa in 2011 to that in 2012?
Give a very brief answer. 1. What is the ratio of the Rating (1=low 6=high) in St. Vincent and the Grenadines in 2011 to that in 2012?
Provide a short and direct response. 1.03. What is the ratio of the Rating (1=low 6=high) of Central African Republic in 2011 to that in 2013?
Provide a succinct answer. 1.13. What is the ratio of the Rating (1=low 6=high) of Samoa in 2011 to that in 2013?
Your answer should be very brief. 1. What is the ratio of the Rating (1=low 6=high) of St. Vincent and the Grenadines in 2011 to that in 2013?
Offer a terse response. 1.03. What is the ratio of the Rating (1=low 6=high) of Central African Republic in 2012 to that in 2013?
Offer a very short reply. 1.13. What is the ratio of the Rating (1=low 6=high) in Samoa in 2012 to that in 2013?
Offer a very short reply. 1. What is the ratio of the Rating (1=low 6=high) of St. Vincent and the Grenadines in 2012 to that in 2013?
Make the answer very short. 1. What is the difference between the highest and the lowest Rating (1=low 6=high) in St. Vincent and the Grenadines?
Provide a short and direct response. 0.2. 